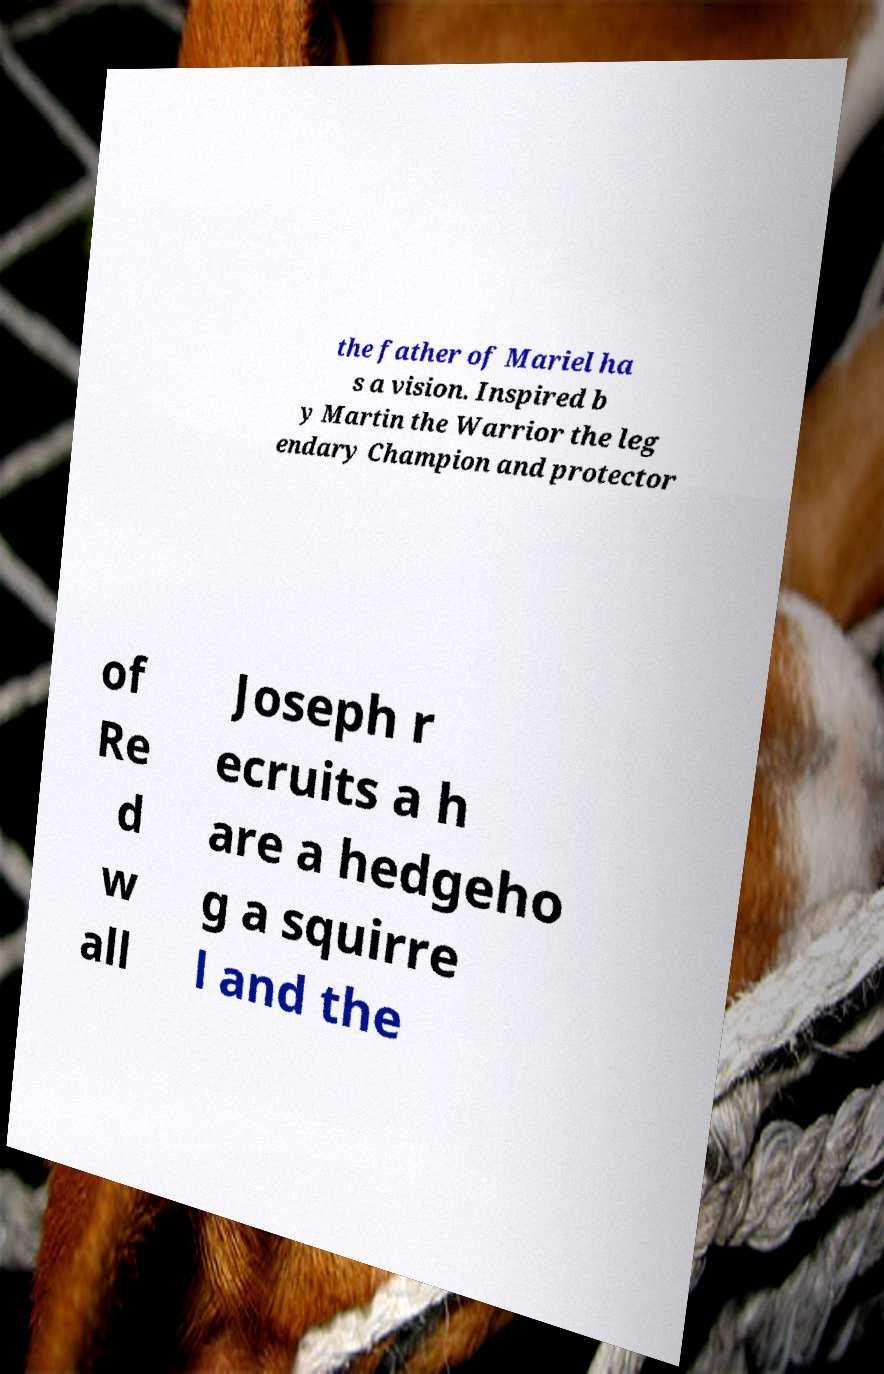Can you accurately transcribe the text from the provided image for me? the father of Mariel ha s a vision. Inspired b y Martin the Warrior the leg endary Champion and protector of Re d w all Joseph r ecruits a h are a hedgeho g a squirre l and the 